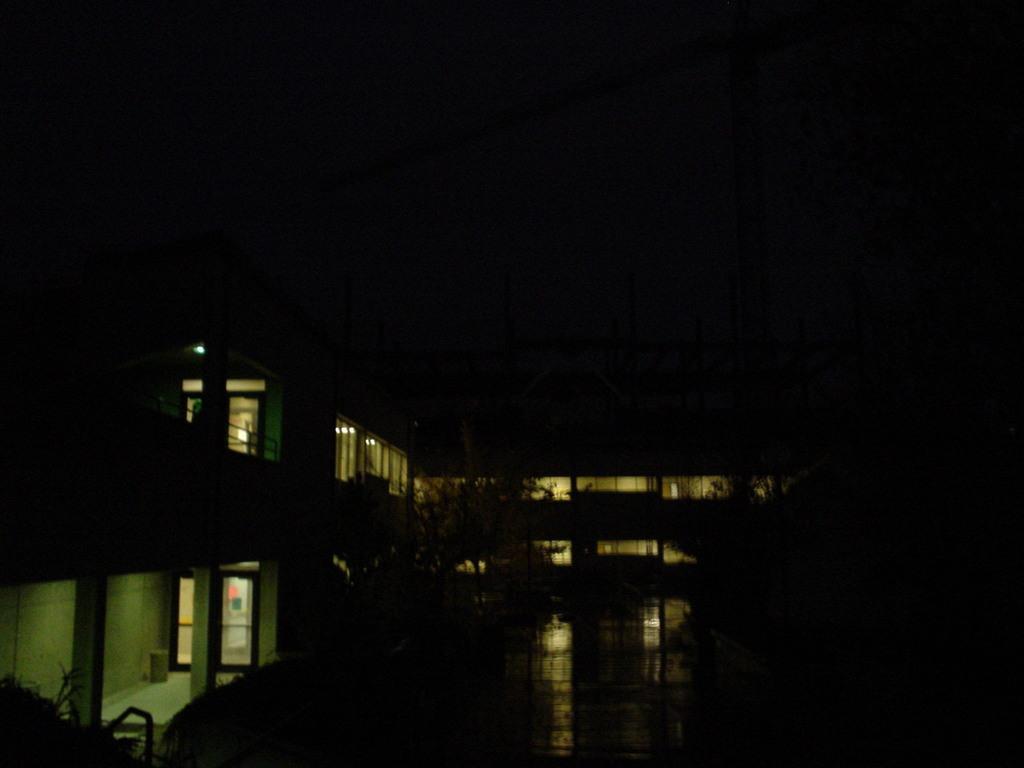Please provide a concise description of this image. This picture is taken during night, in the picture I can see buildings, in front of buildings I can see trees. 